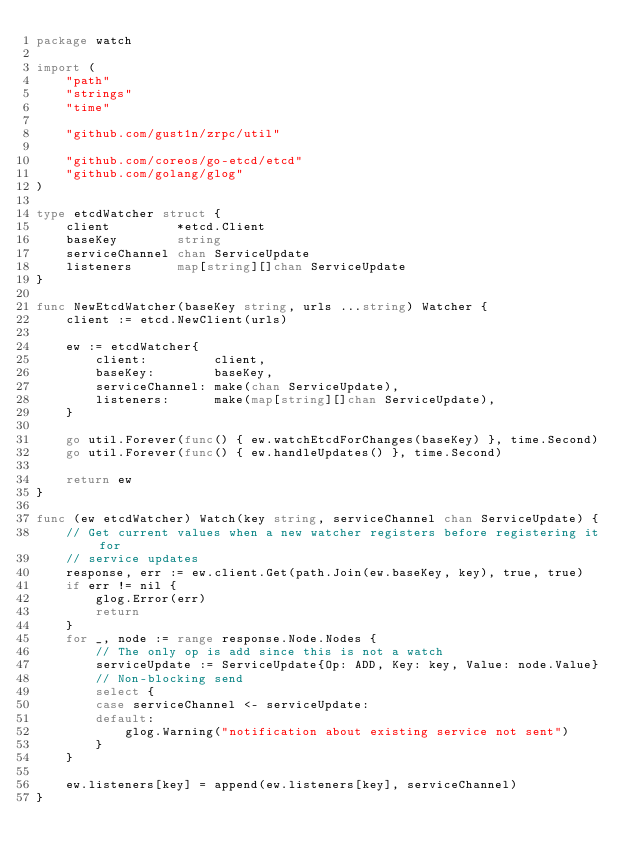<code> <loc_0><loc_0><loc_500><loc_500><_Go_>package watch

import (
	"path"
	"strings"
	"time"

	"github.com/gust1n/zrpc/util"

	"github.com/coreos/go-etcd/etcd"
	"github.com/golang/glog"
)

type etcdWatcher struct {
	client         *etcd.Client
	baseKey        string
	serviceChannel chan ServiceUpdate
	listeners      map[string][]chan ServiceUpdate
}

func NewEtcdWatcher(baseKey string, urls ...string) Watcher {
	client := etcd.NewClient(urls)

	ew := etcdWatcher{
		client:         client,
		baseKey:        baseKey,
		serviceChannel: make(chan ServiceUpdate),
		listeners:      make(map[string][]chan ServiceUpdate),
	}

	go util.Forever(func() { ew.watchEtcdForChanges(baseKey) }, time.Second)
	go util.Forever(func() { ew.handleUpdates() }, time.Second)

	return ew
}

func (ew etcdWatcher) Watch(key string, serviceChannel chan ServiceUpdate) {
	// Get current values when a new watcher registers before registering it for
	// service updates
	response, err := ew.client.Get(path.Join(ew.baseKey, key), true, true)
	if err != nil {
		glog.Error(err)
		return
	}
	for _, node := range response.Node.Nodes {
		// The only op is add since this is not a watch
		serviceUpdate := ServiceUpdate{Op: ADD, Key: key, Value: node.Value}
		// Non-blocking send
		select {
		case serviceChannel <- serviceUpdate:
		default:
			glog.Warning("notification about existing service not sent")
		}
	}

	ew.listeners[key] = append(ew.listeners[key], serviceChannel)
}
</code> 